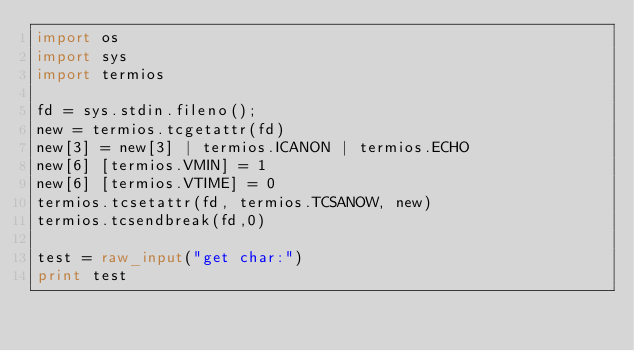Convert code to text. <code><loc_0><loc_0><loc_500><loc_500><_Python_>import os
import sys
import termios

fd = sys.stdin.fileno();
new = termios.tcgetattr(fd)
new[3] = new[3] | termios.ICANON | termios.ECHO
new[6] [termios.VMIN] = 1
new[6] [termios.VTIME] = 0
termios.tcsetattr(fd, termios.TCSANOW, new)
termios.tcsendbreak(fd,0)

test = raw_input("get char:")
print test</code> 